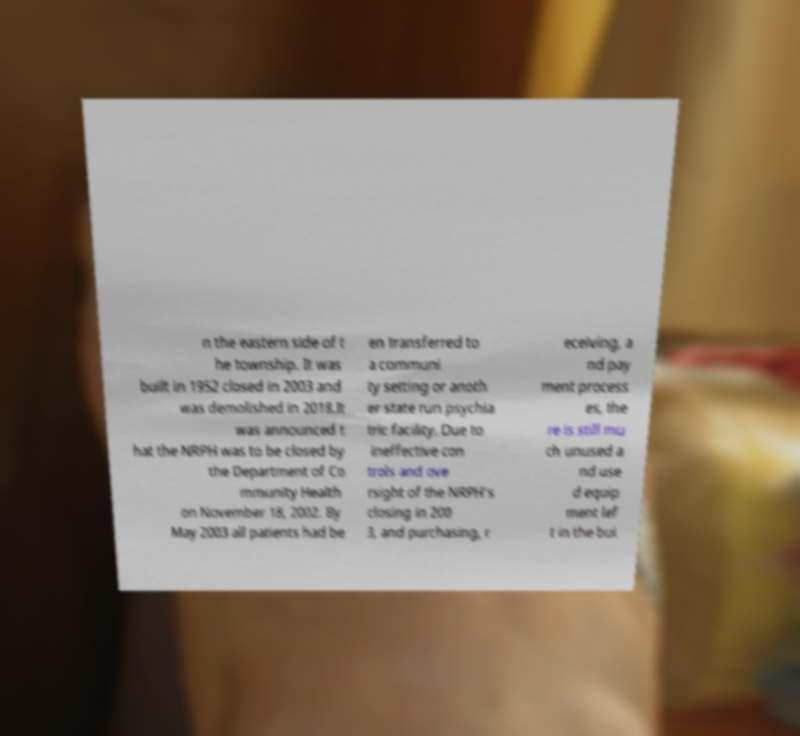What messages or text are displayed in this image? I need them in a readable, typed format. n the eastern side of t he township. It was built in 1952 closed in 2003 and was demolished in 2018.It was announced t hat the NRPH was to be closed by the Department of Co mmunity Health on November 18, 2002. By May 2003 all patients had be en transferred to a communi ty setting or anoth er state run psychia tric facility. Due to ineffective con trols and ove rsight of the NRPH's closing in 200 3, and purchasing, r eceiving, a nd pay ment process es, the re is still mu ch unused a nd use d equip ment lef t in the bui 